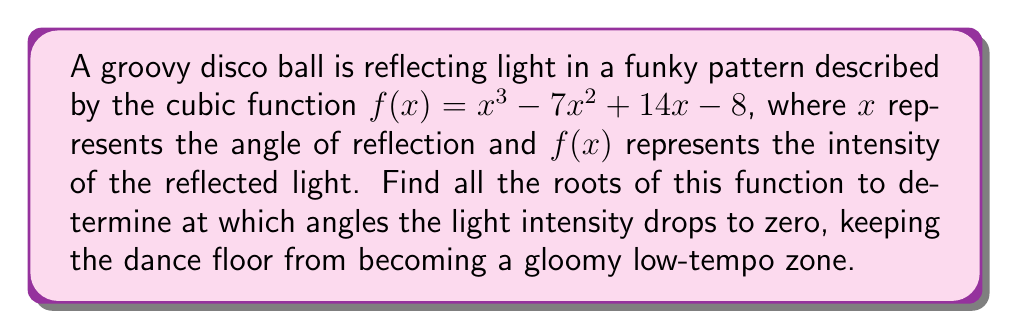What is the answer to this math problem? To find the roots of the cubic function $f(x) = x^3 - 7x^2 + 14x - 8$, we need to solve the equation $f(x) = 0$. Let's break it down step by step:

1) First, let's check if there are any rational roots using the rational root theorem. The possible rational roots are the factors of the constant term (8): ±1, ±2, ±4, ±8.

2) Testing these values, we find that $f(1) = 0$. So $x = 1$ is a root.

3) Now we can factor out $(x - 1)$ from the original function:

   $f(x) = (x - 1)(x^2 - 6x + 8)$

4) We're left with a quadratic equation to solve: $x^2 - 6x + 8 = 0$

5) We can solve this using the quadratic formula: $x = \frac{-b \pm \sqrt{b^2 - 4ac}}{2a}$

   Where $a = 1$, $b = -6$, and $c = 8$

6) Plugging in these values:

   $x = \frac{6 \pm \sqrt{36 - 32}}{2} = \frac{6 \pm \sqrt{4}}{2} = \frac{6 \pm 2}{2}$

7) This gives us two more roots:

   $x = \frac{6 + 2}{2} = 4$ and $x = \frac{6 - 2}{2} = 2$

Therefore, the three roots of the function are 1, 2, and 4.
Answer: The roots of the function are $x = 1$, $x = 2$, and $x = 4$. 